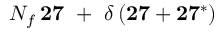Convert formula to latex. <formula><loc_0><loc_0><loc_500><loc_500>N _ { f } \, { 2 7 } \ + \ \delta \, ( { 2 7 } + { 2 7 ^ { * } } )</formula> 